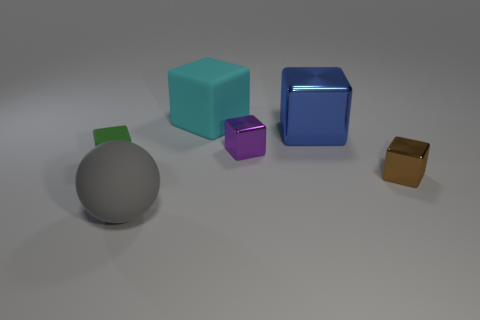Is the size of the gray rubber sphere the same as the brown metallic block?
Make the answer very short. No. How many cylinders are gray things or metal objects?
Provide a short and direct response. 0. There is a big object that is in front of the brown metal object; how many big things are behind it?
Your answer should be compact. 2. Does the brown object have the same shape as the cyan object?
Keep it short and to the point. Yes. There is a blue metallic object that is the same shape as the small purple shiny object; what is its size?
Ensure brevity in your answer.  Large. There is a thing that is left of the rubber object that is in front of the brown shiny thing; what shape is it?
Give a very brief answer. Cube. What size is the blue metallic block?
Provide a short and direct response. Large. The big cyan rubber thing has what shape?
Give a very brief answer. Cube. There is a big blue shiny object; is it the same shape as the large thing behind the blue metal thing?
Your answer should be compact. Yes. Is the shape of the small metallic thing that is behind the tiny matte object the same as  the big cyan thing?
Offer a terse response. Yes. 